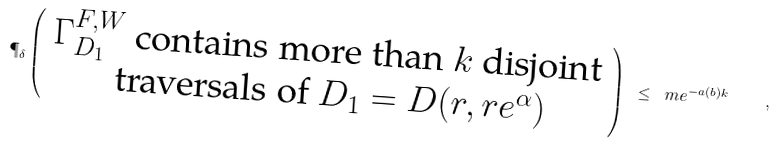<formula> <loc_0><loc_0><loc_500><loc_500>\P _ { \delta } \left ( \begin{array} { c } \text {$\Gamma^{F,W}_{D_{1}}$ contains more than $k$ disjoint} \\ \text { traversals  of $D_{1}=D(r, r e^{\alpha }) $} \end{array} \right ) \ \leq \ m e ^ { - a ( b ) k } \quad ,</formula> 